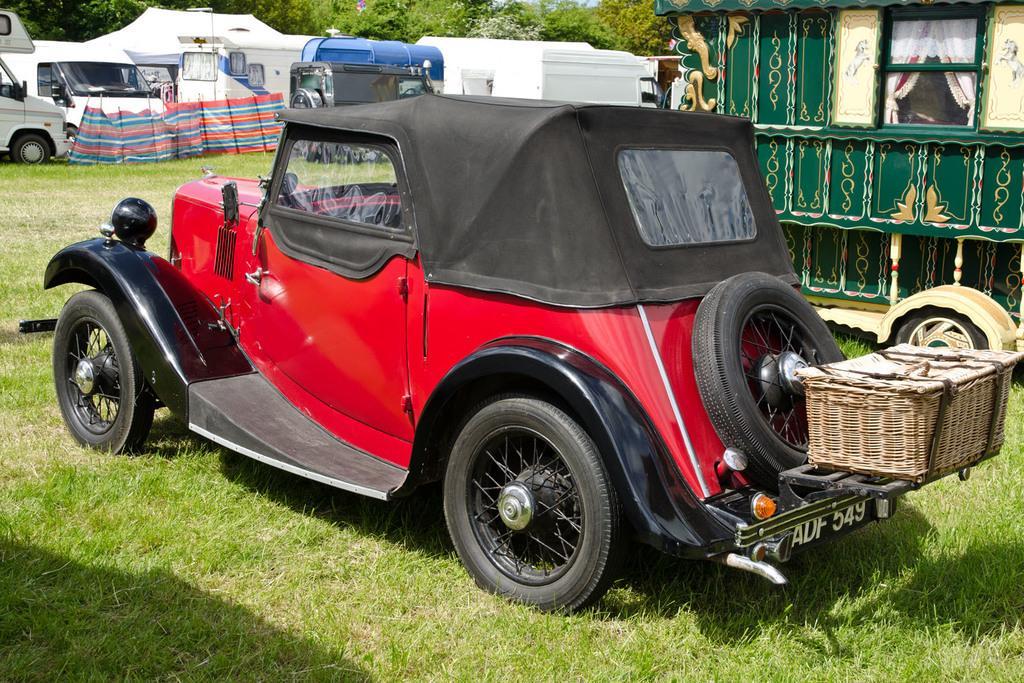How would you summarize this image in a sentence or two? As we can see in the image there is grass, red color truck, cars, buildings and trees. 